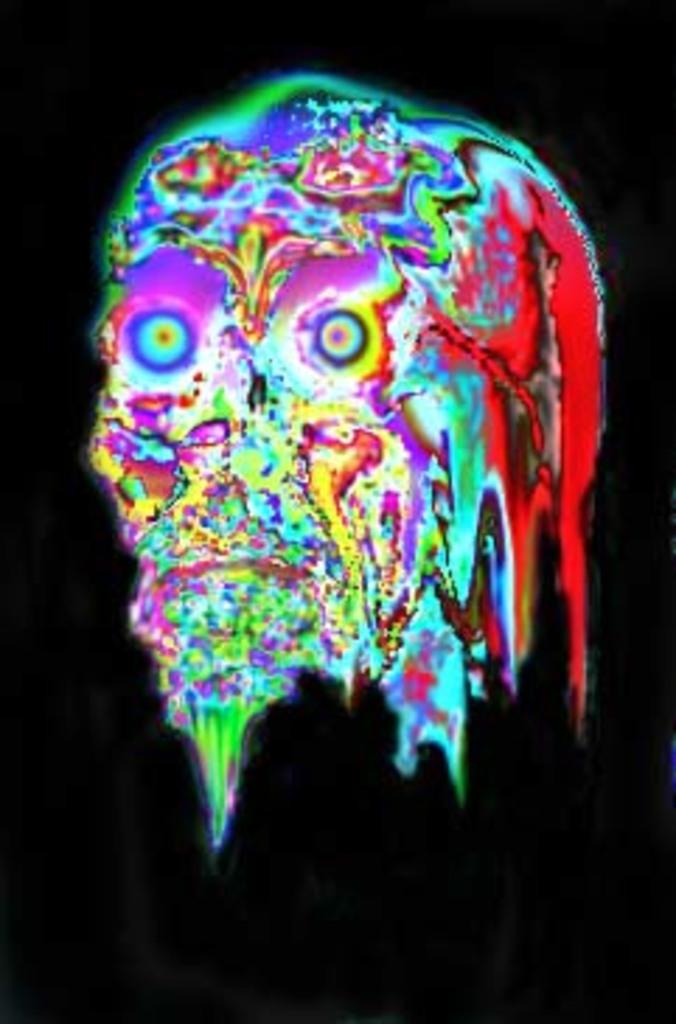What type of animation is present in the image? There is an animation in the form of a skull in the image. What type of roof can be seen on the map in the image? There is no map or roof present in the image; it features an animated skull. 